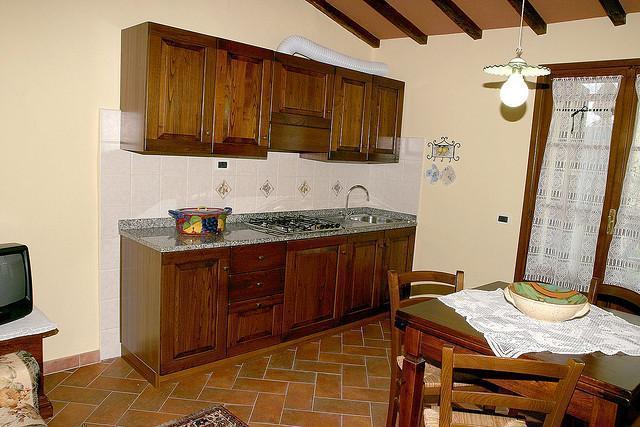What is the white tube on top of the cabinet used for?
Select the correct answer and articulate reasoning with the following format: 'Answer: answer
Rationale: rationale.'
Options: Heating, ventilation, air conditioning, water. Answer: ventilation.
Rationale: There is set of wood cabinets against the wall and in the middle a white   pliable hose. it is used to vent out the stove to pull hot air out of. 